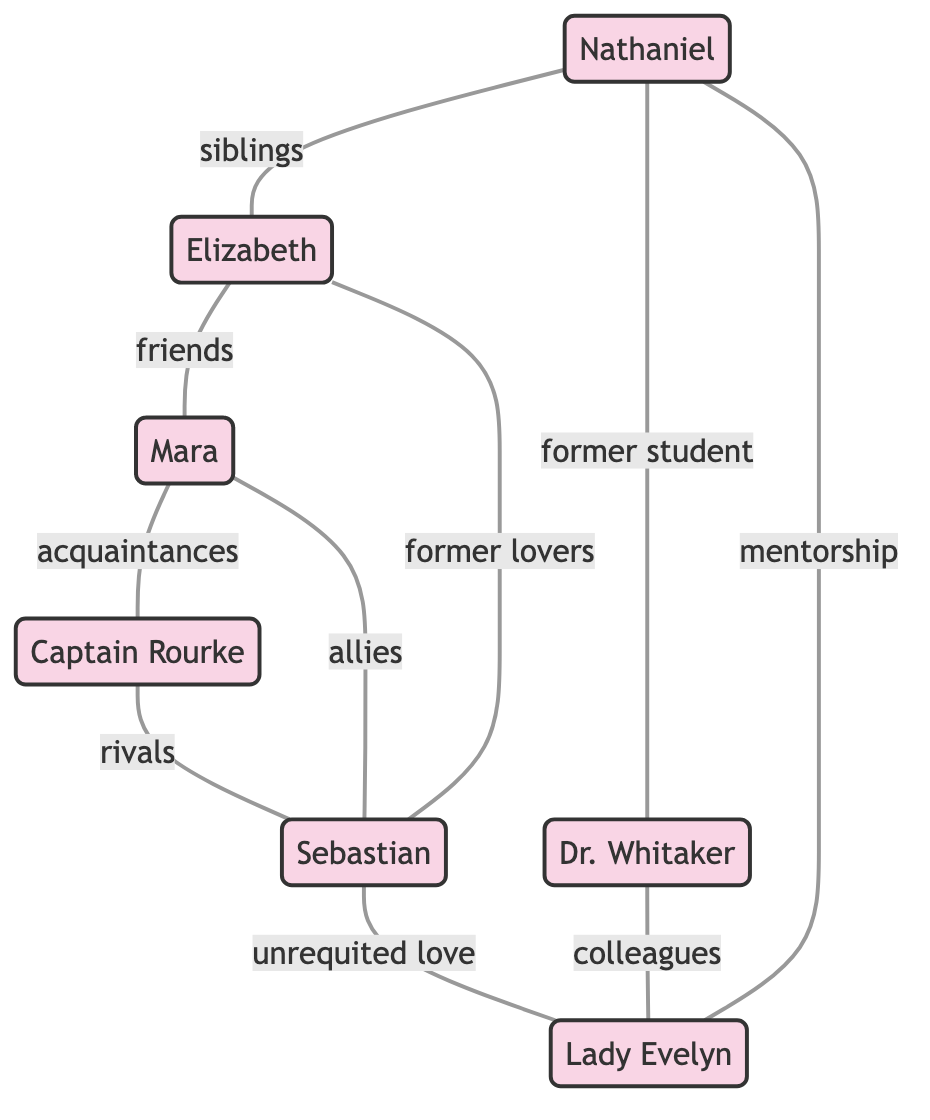What is the relationship between Nathaniel and Elizabeth? The diagram shows that Nathaniel and Elizabeth are connected with the label "siblings," indicating their familial relationship.
Answer: siblings How many characters are there in the diagram? By counting the number of nodes provided, we find that there are seven distinct characters in the diagram.
Answer: 7 Which character is a mentor to Nathaniel? In the diagram, a connection with the label "mentorship" leads from Lady Evelyn to Nathaniel, indicating that she plays a mentorship role for him.
Answer: Lady Evelyn Who are the allies of Sebastian? The diagram indicates that Mara is identified as an ally of Sebastian, connected by the label "allies," attributing a supportive relationship between them.
Answer: Mara What type of relationship exists between Captain Rourke and Sebastian? The diagram illustrates a connection between Captain Rourke and Sebastian labeled as "rivals," demonstrating their opposing positions.
Answer: rivals How many relationships are shown in total in the diagram? By counting the number of edges listed, we find that there are ten distinct relationships represented in this diagram.
Answer: 10 Which character has unrequited love for Lady Evelyn? The diagram shows a connection from Sebastian to Lady Evelyn labeled as "unrequited love," making it clear that Sebastian harbors this feeling towards her.
Answer: Sebastian What is the relationship between Mara and Captain Rourke? The diagram indicates a connection between Mara and Captain Rourke labeled as "acquaintances," showing they know each other but aren't close.
Answer: acquaintances Which character is described as a former student of Dr. Whitaker? The connection from Nathaniel to Dr. Whitaker labeled as "former student" clarifies that Nathaniel was once a student of Dr. Whitaker.
Answer: Nathaniel Which two characters are former lovers? Elizabeth and Sebastian are connected with the label "former lovers," indicating that they have a past romantic relationship.
Answer: Elizabeth and Sebastian 